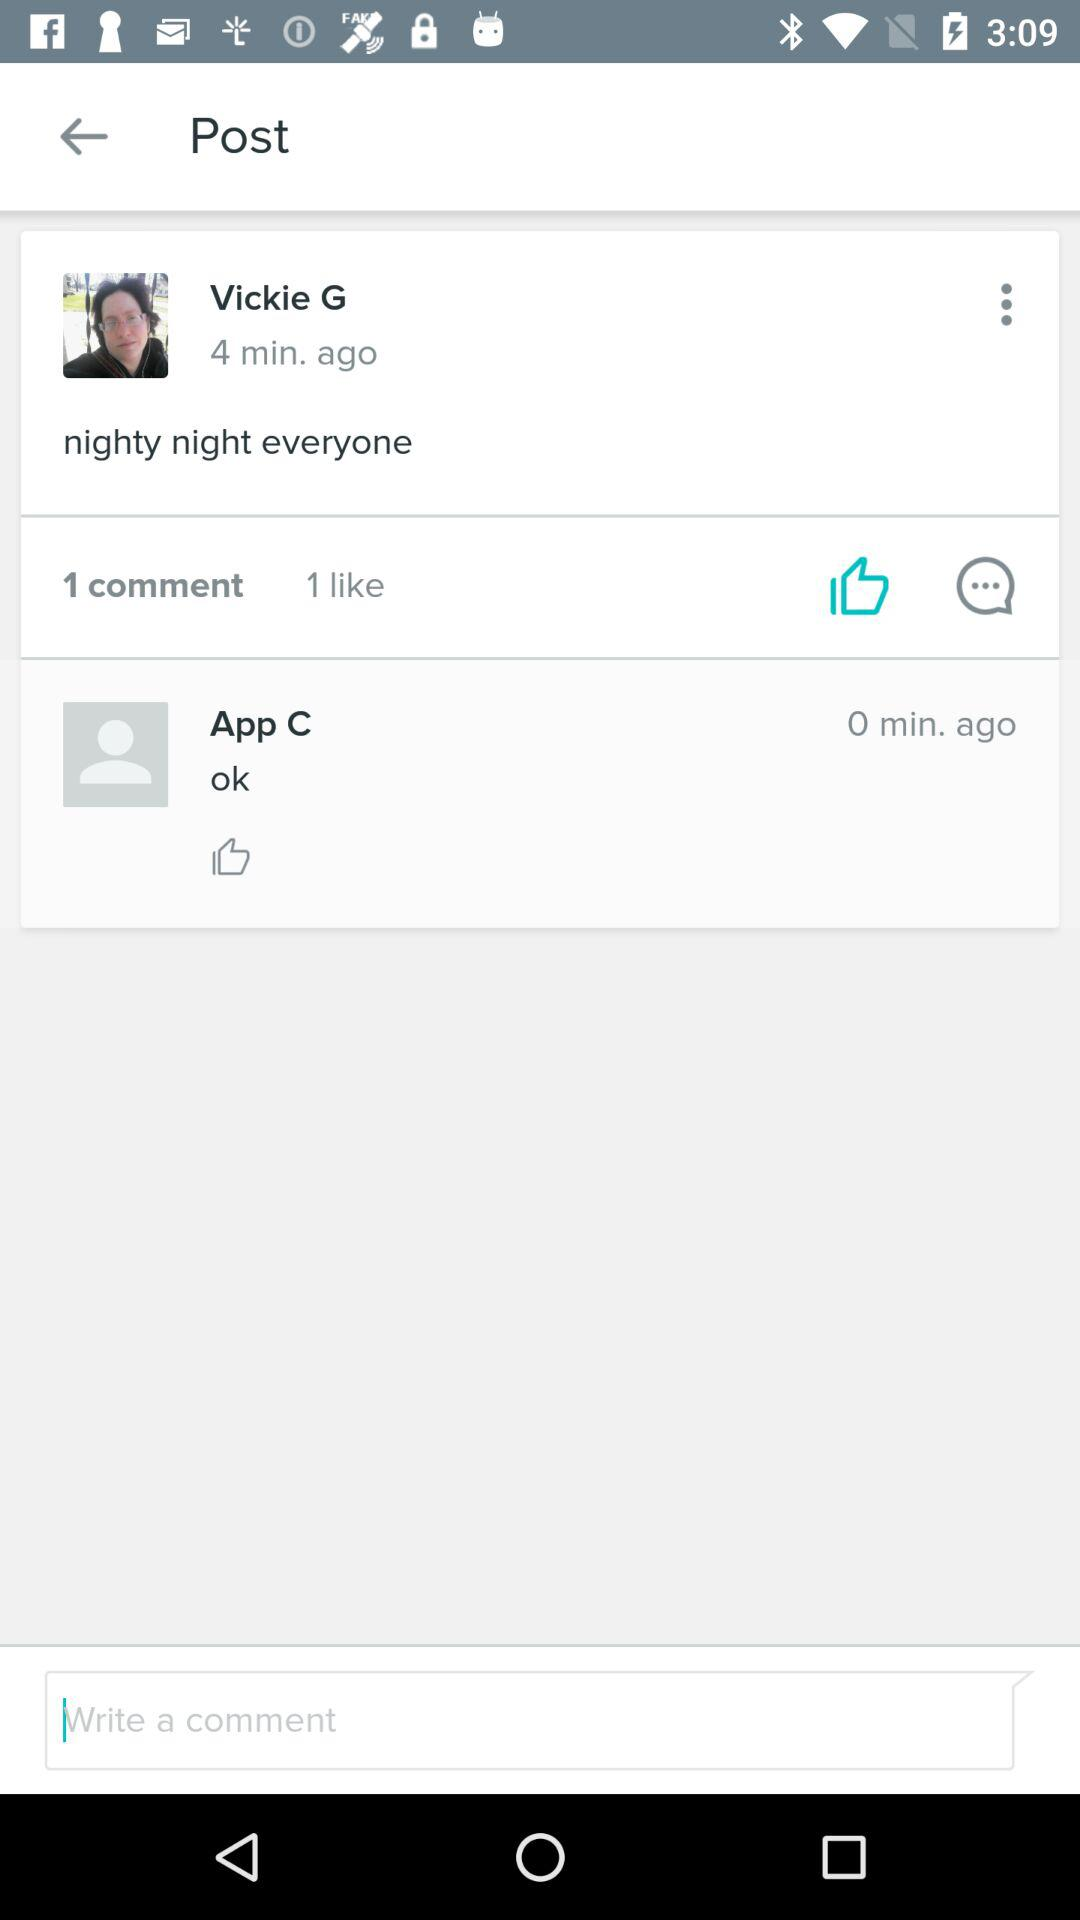Who has posted the post? The post has posted by Vickie G. 